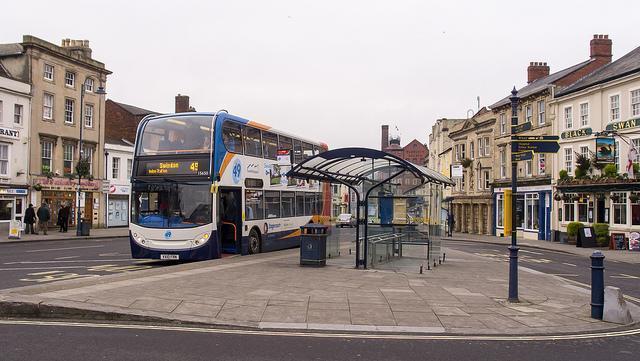What is the round blue bin used to collect?
Make your selection from the four choices given to correctly answer the question.
Options: Candy, mail, rain, trash. Trash. 